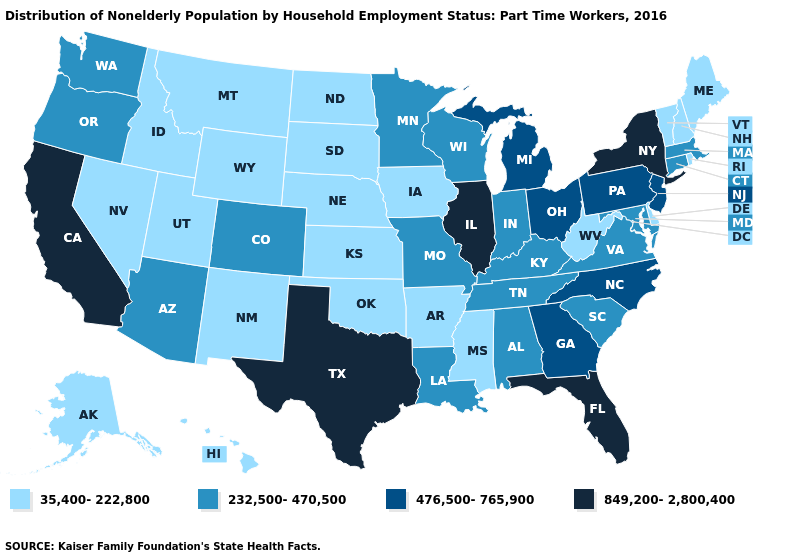Name the states that have a value in the range 232,500-470,500?
Be succinct. Alabama, Arizona, Colorado, Connecticut, Indiana, Kentucky, Louisiana, Maryland, Massachusetts, Minnesota, Missouri, Oregon, South Carolina, Tennessee, Virginia, Washington, Wisconsin. Does the map have missing data?
Give a very brief answer. No. Does Washington have the lowest value in the USA?
Give a very brief answer. No. Among the states that border Iowa , does Nebraska have the lowest value?
Answer briefly. Yes. Name the states that have a value in the range 849,200-2,800,400?
Quick response, please. California, Florida, Illinois, New York, Texas. What is the value of Maryland?
Quick response, please. 232,500-470,500. Which states have the lowest value in the USA?
Keep it brief. Alaska, Arkansas, Delaware, Hawaii, Idaho, Iowa, Kansas, Maine, Mississippi, Montana, Nebraska, Nevada, New Hampshire, New Mexico, North Dakota, Oklahoma, Rhode Island, South Dakota, Utah, Vermont, West Virginia, Wyoming. Among the states that border Rhode Island , which have the highest value?
Be succinct. Connecticut, Massachusetts. What is the value of Oregon?
Quick response, please. 232,500-470,500. Name the states that have a value in the range 476,500-765,900?
Keep it brief. Georgia, Michigan, New Jersey, North Carolina, Ohio, Pennsylvania. Does Florida have the same value as Kansas?
Answer briefly. No. Does the map have missing data?
Quick response, please. No. What is the highest value in the USA?
Answer briefly. 849,200-2,800,400. What is the lowest value in the MidWest?
Quick response, please. 35,400-222,800. Does the map have missing data?
Keep it brief. No. 